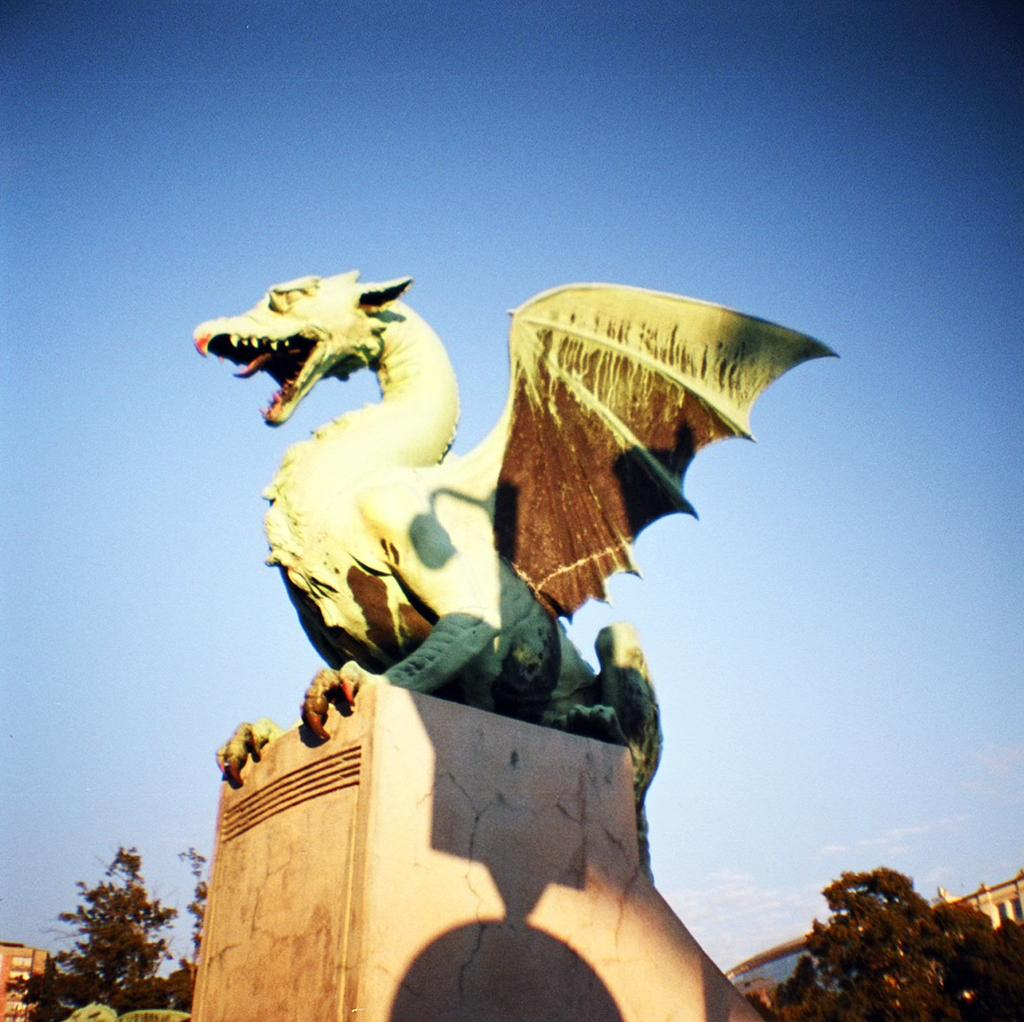What is the main subject in the foreground of the image? There is a sculpture of an animal in the foreground. What type of natural elements can be seen in the image? There are plants and trees in the image. What type of man-made structures are visible in the background? There are buildings in the background. What part of the natural environment is visible in the image? The sky is visible in the background. Can you make an assumption about the time of day the image was taken? The image might have been taken during the day, as the sky is visible and there is no indication of darkness. Can you tell me what type of guitar the animal is playing in the image? There is no guitar present in the image; the main subject is a sculpture of an animal. Is there a parent in the image supervising the animal's activities? There is no indication of a parent or any other person in the image; it only features a sculpture of an animal, plants, trees, buildings, and the sky. 